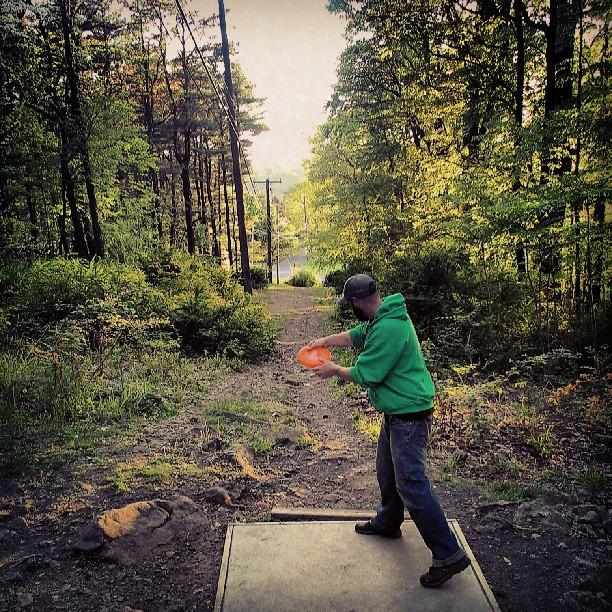The ground that the man is standing on is made of what material?

Choices:
A) cement
B) wood
C) ceramic
D) soil cement 